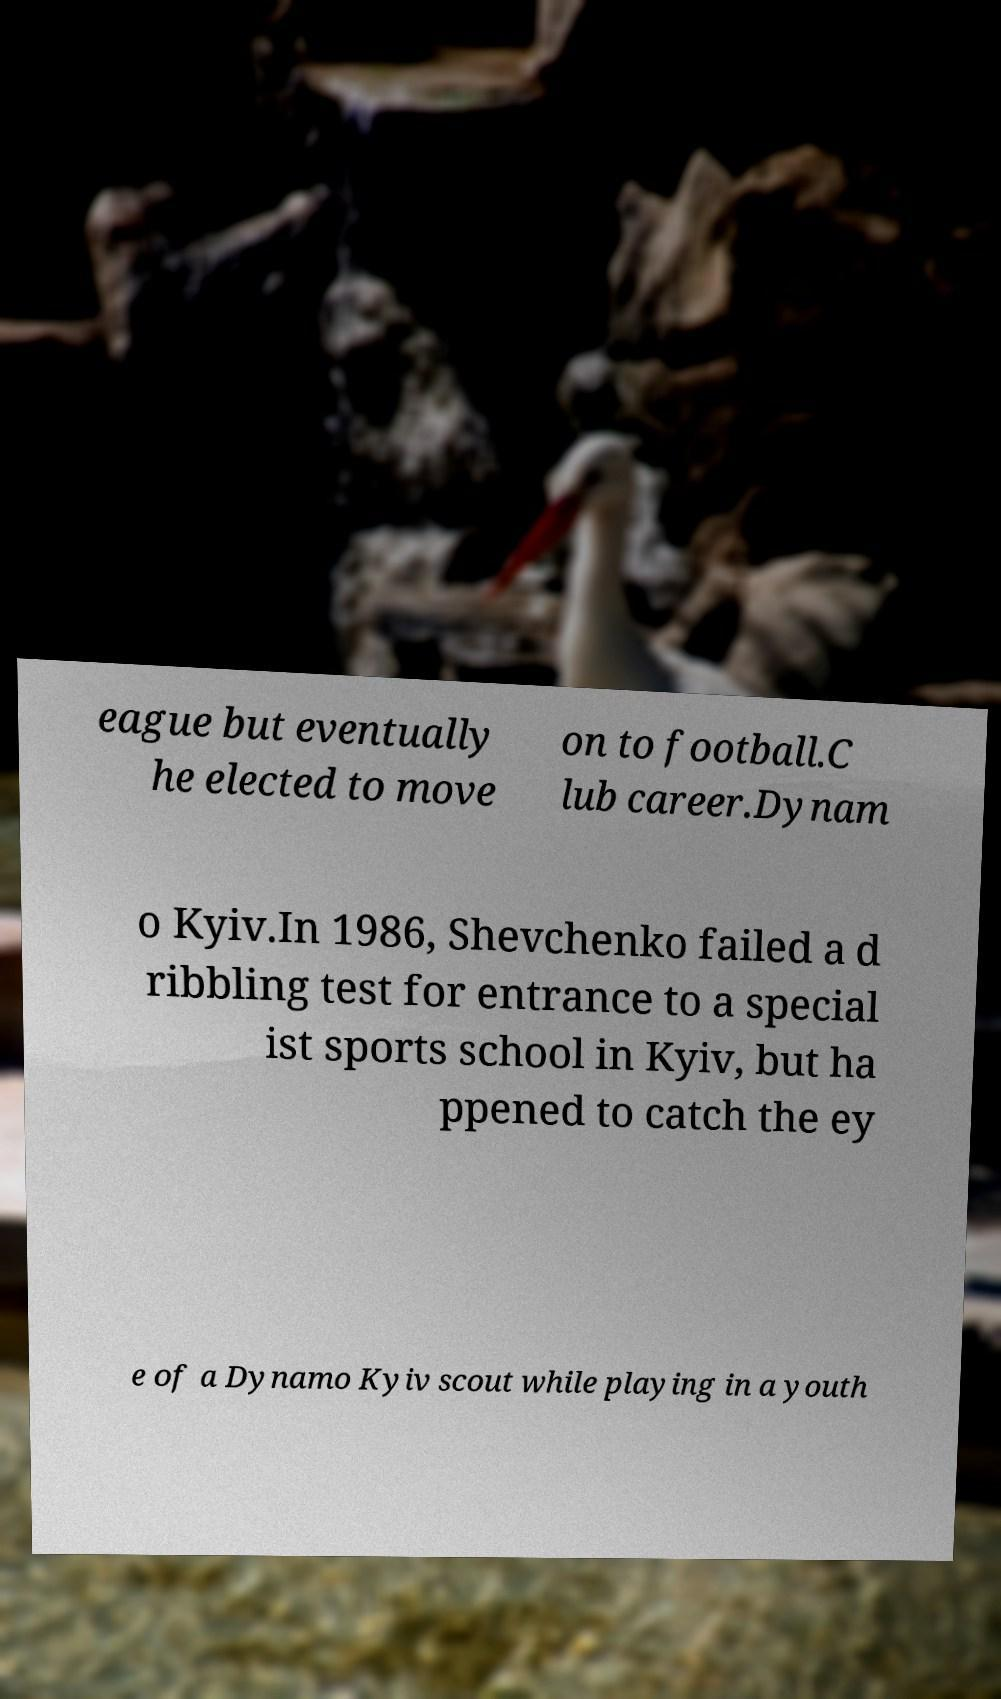For documentation purposes, I need the text within this image transcribed. Could you provide that? eague but eventually he elected to move on to football.C lub career.Dynam o Kyiv.In 1986, Shevchenko failed a d ribbling test for entrance to a special ist sports school in Kyiv, but ha ppened to catch the ey e of a Dynamo Kyiv scout while playing in a youth 